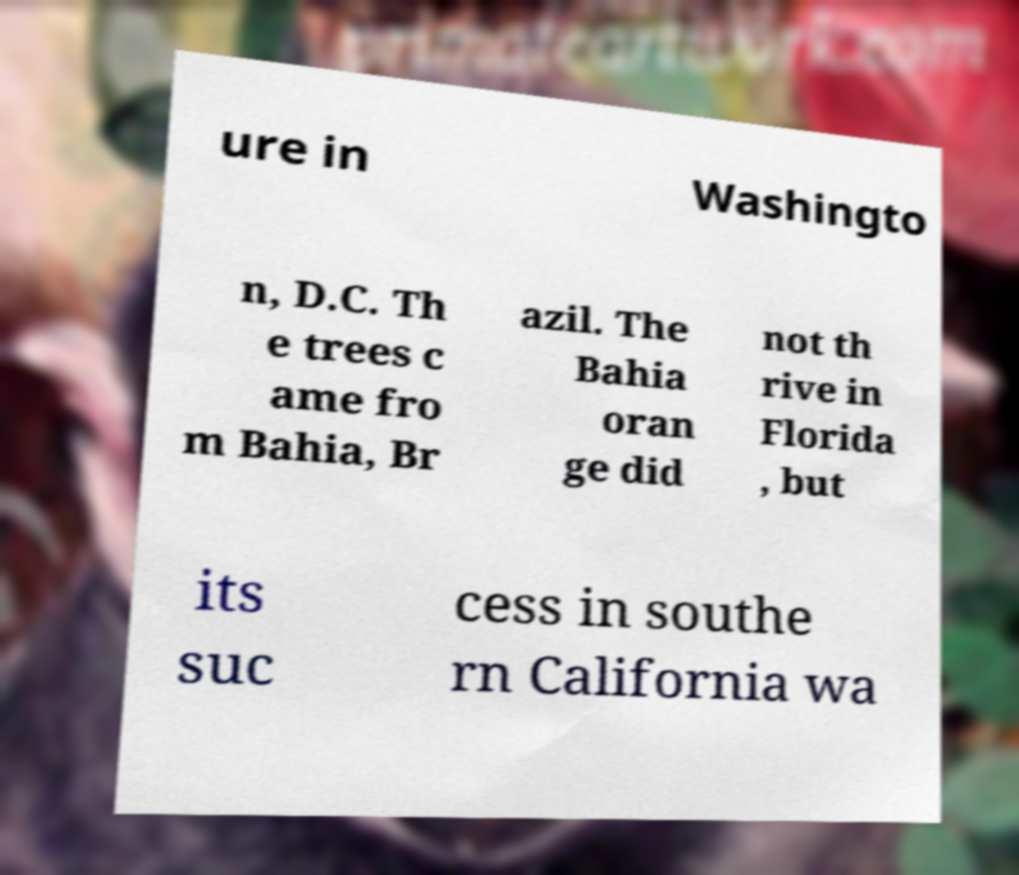There's text embedded in this image that I need extracted. Can you transcribe it verbatim? ure in Washingto n, D.C. Th e trees c ame fro m Bahia, Br azil. The Bahia oran ge did not th rive in Florida , but its suc cess in southe rn California wa 